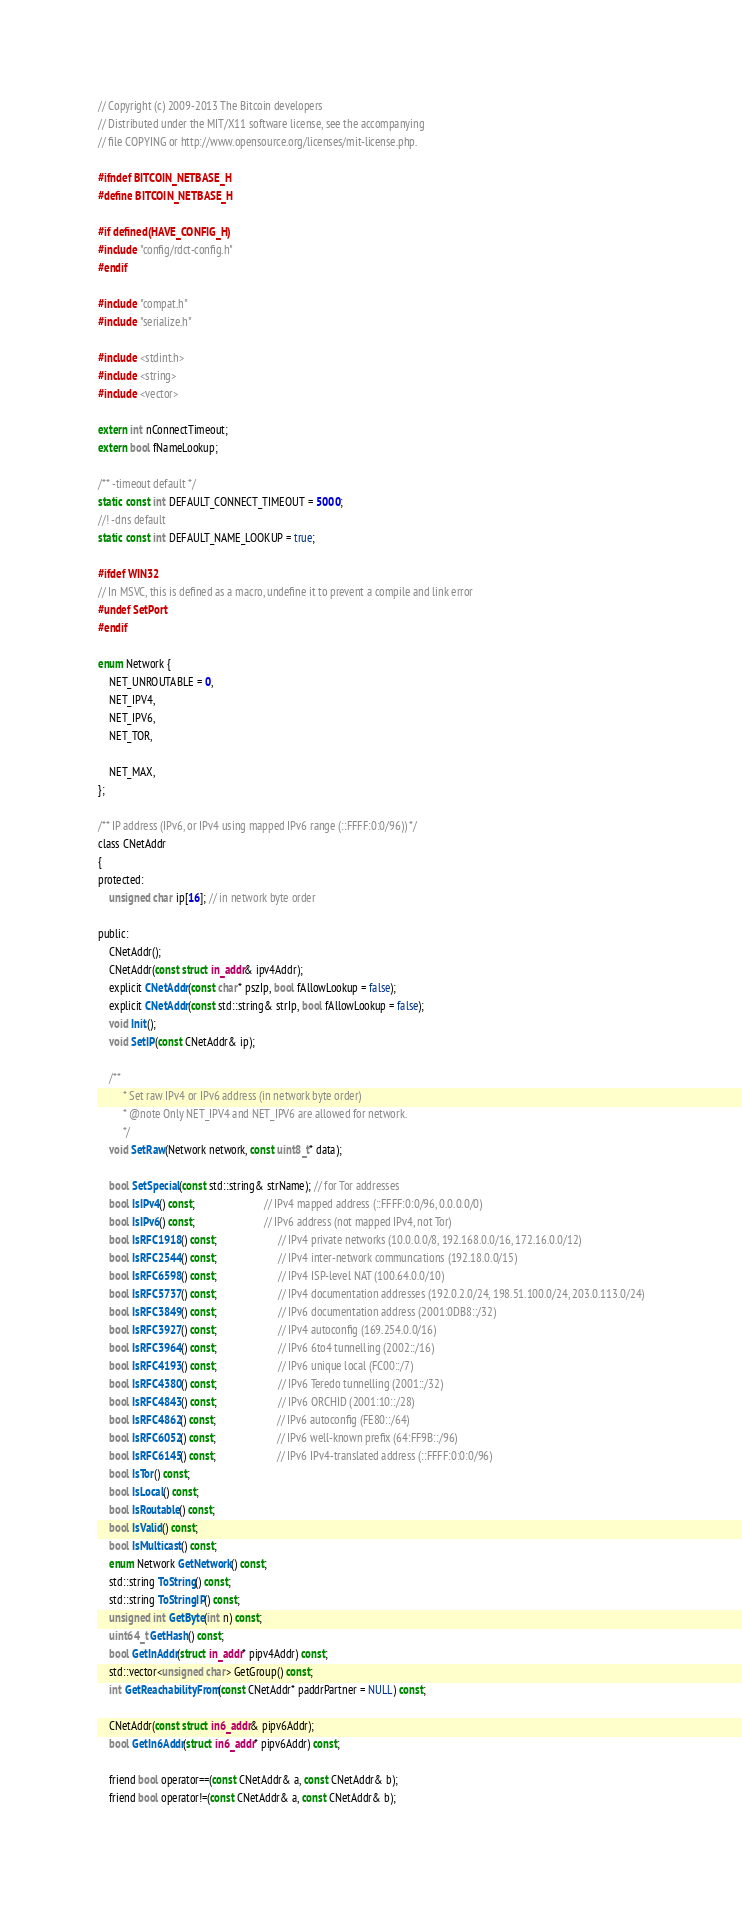<code> <loc_0><loc_0><loc_500><loc_500><_C_>// Copyright (c) 2009-2013 The Bitcoin developers
// Distributed under the MIT/X11 software license, see the accompanying
// file COPYING or http://www.opensource.org/licenses/mit-license.php.

#ifndef BITCOIN_NETBASE_H
#define BITCOIN_NETBASE_H

#if defined(HAVE_CONFIG_H)
#include "config/rdct-config.h"
#endif

#include "compat.h"
#include "serialize.h"

#include <stdint.h>
#include <string>
#include <vector>

extern int nConnectTimeout;
extern bool fNameLookup;

/** -timeout default */
static const int DEFAULT_CONNECT_TIMEOUT = 5000;
//! -dns default
static const int DEFAULT_NAME_LOOKUP = true;

#ifdef WIN32
// In MSVC, this is defined as a macro, undefine it to prevent a compile and link error
#undef SetPort
#endif

enum Network {
    NET_UNROUTABLE = 0,
    NET_IPV4,
    NET_IPV6,
    NET_TOR,

    NET_MAX,
};

/** IP address (IPv6, or IPv4 using mapped IPv6 range (::FFFF:0:0/96)) */
class CNetAddr
{
protected:
    unsigned char ip[16]; // in network byte order

public:
    CNetAddr();
    CNetAddr(const struct in_addr& ipv4Addr);
    explicit CNetAddr(const char* pszIp, bool fAllowLookup = false);
    explicit CNetAddr(const std::string& strIp, bool fAllowLookup = false);
    void Init();
    void SetIP(const CNetAddr& ip);

    /**
         * Set raw IPv4 or IPv6 address (in network byte order)
         * @note Only NET_IPV4 and NET_IPV6 are allowed for network.
         */
    void SetRaw(Network network, const uint8_t* data);

    bool SetSpecial(const std::string& strName); // for Tor addresses
    bool IsIPv4() const;                         // IPv4 mapped address (::FFFF:0:0/96, 0.0.0.0/0)
    bool IsIPv6() const;                         // IPv6 address (not mapped IPv4, not Tor)
    bool IsRFC1918() const;                      // IPv4 private networks (10.0.0.0/8, 192.168.0.0/16, 172.16.0.0/12)
    bool IsRFC2544() const;                      // IPv4 inter-network communcations (192.18.0.0/15)
    bool IsRFC6598() const;                      // IPv4 ISP-level NAT (100.64.0.0/10)
    bool IsRFC5737() const;                      // IPv4 documentation addresses (192.0.2.0/24, 198.51.100.0/24, 203.0.113.0/24)
    bool IsRFC3849() const;                      // IPv6 documentation address (2001:0DB8::/32)
    bool IsRFC3927() const;                      // IPv4 autoconfig (169.254.0.0/16)
    bool IsRFC3964() const;                      // IPv6 6to4 tunnelling (2002::/16)
    bool IsRFC4193() const;                      // IPv6 unique local (FC00::/7)
    bool IsRFC4380() const;                      // IPv6 Teredo tunnelling (2001::/32)
    bool IsRFC4843() const;                      // IPv6 ORCHID (2001:10::/28)
    bool IsRFC4862() const;                      // IPv6 autoconfig (FE80::/64)
    bool IsRFC6052() const;                      // IPv6 well-known prefix (64:FF9B::/96)
    bool IsRFC6145() const;                      // IPv6 IPv4-translated address (::FFFF:0:0:0/96)
    bool IsTor() const;
    bool IsLocal() const;
    bool IsRoutable() const;
    bool IsValid() const;
    bool IsMulticast() const;
    enum Network GetNetwork() const;
    std::string ToString() const;
    std::string ToStringIP() const;
    unsigned int GetByte(int n) const;
    uint64_t GetHash() const;
    bool GetInAddr(struct in_addr* pipv4Addr) const;
    std::vector<unsigned char> GetGroup() const;
    int GetReachabilityFrom(const CNetAddr* paddrPartner = NULL) const;

    CNetAddr(const struct in6_addr& pipv6Addr);
    bool GetIn6Addr(struct in6_addr* pipv6Addr) const;

    friend bool operator==(const CNetAddr& a, const CNetAddr& b);
    friend bool operator!=(const CNetAddr& a, const CNetAddr& b);</code> 